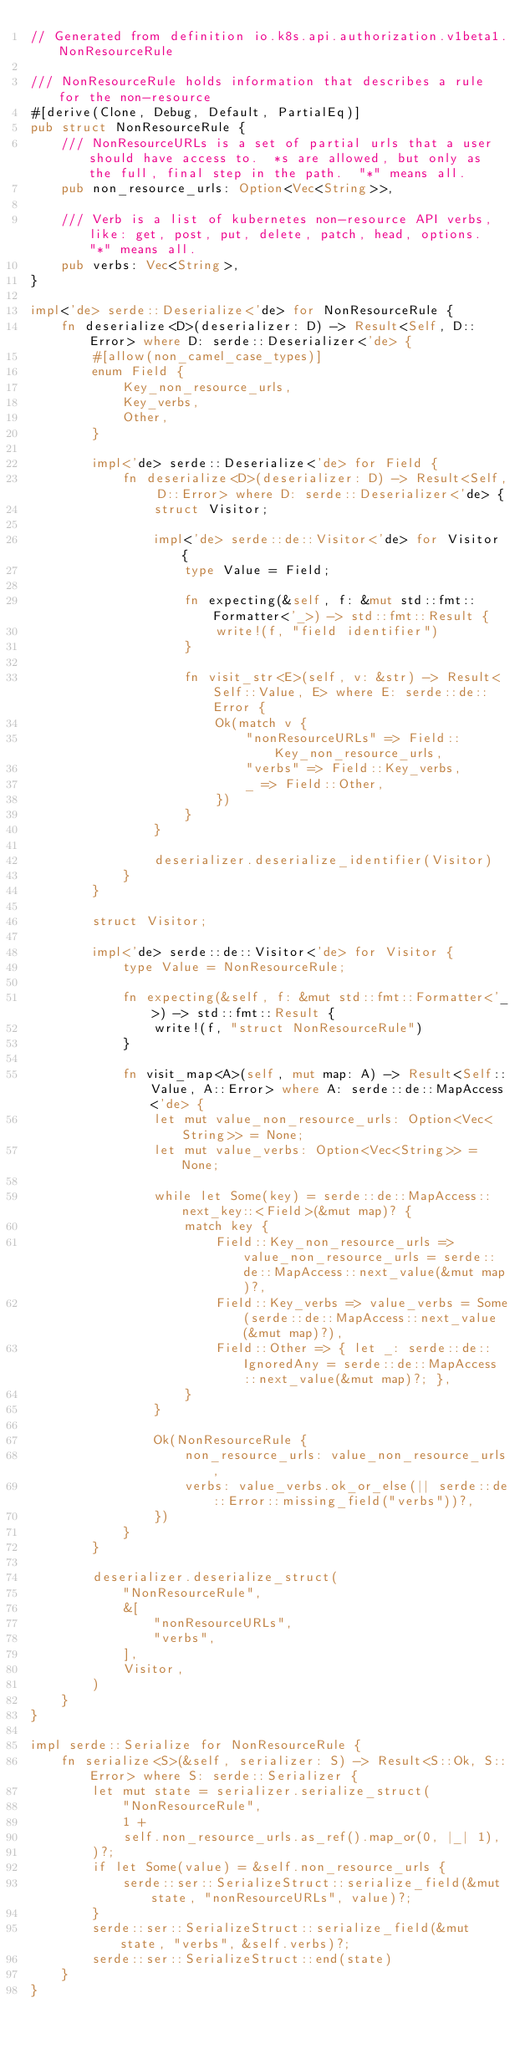<code> <loc_0><loc_0><loc_500><loc_500><_Rust_>// Generated from definition io.k8s.api.authorization.v1beta1.NonResourceRule

/// NonResourceRule holds information that describes a rule for the non-resource
#[derive(Clone, Debug, Default, PartialEq)]
pub struct NonResourceRule {
    /// NonResourceURLs is a set of partial urls that a user should have access to.  *s are allowed, but only as the full, final step in the path.  "*" means all.
    pub non_resource_urls: Option<Vec<String>>,

    /// Verb is a list of kubernetes non-resource API verbs, like: get, post, put, delete, patch, head, options.  "*" means all.
    pub verbs: Vec<String>,
}

impl<'de> serde::Deserialize<'de> for NonResourceRule {
    fn deserialize<D>(deserializer: D) -> Result<Self, D::Error> where D: serde::Deserializer<'de> {
        #[allow(non_camel_case_types)]
        enum Field {
            Key_non_resource_urls,
            Key_verbs,
            Other,
        }

        impl<'de> serde::Deserialize<'de> for Field {
            fn deserialize<D>(deserializer: D) -> Result<Self, D::Error> where D: serde::Deserializer<'de> {
                struct Visitor;

                impl<'de> serde::de::Visitor<'de> for Visitor {
                    type Value = Field;

                    fn expecting(&self, f: &mut std::fmt::Formatter<'_>) -> std::fmt::Result {
                        write!(f, "field identifier")
                    }

                    fn visit_str<E>(self, v: &str) -> Result<Self::Value, E> where E: serde::de::Error {
                        Ok(match v {
                            "nonResourceURLs" => Field::Key_non_resource_urls,
                            "verbs" => Field::Key_verbs,
                            _ => Field::Other,
                        })
                    }
                }

                deserializer.deserialize_identifier(Visitor)
            }
        }

        struct Visitor;

        impl<'de> serde::de::Visitor<'de> for Visitor {
            type Value = NonResourceRule;

            fn expecting(&self, f: &mut std::fmt::Formatter<'_>) -> std::fmt::Result {
                write!(f, "struct NonResourceRule")
            }

            fn visit_map<A>(self, mut map: A) -> Result<Self::Value, A::Error> where A: serde::de::MapAccess<'de> {
                let mut value_non_resource_urls: Option<Vec<String>> = None;
                let mut value_verbs: Option<Vec<String>> = None;

                while let Some(key) = serde::de::MapAccess::next_key::<Field>(&mut map)? {
                    match key {
                        Field::Key_non_resource_urls => value_non_resource_urls = serde::de::MapAccess::next_value(&mut map)?,
                        Field::Key_verbs => value_verbs = Some(serde::de::MapAccess::next_value(&mut map)?),
                        Field::Other => { let _: serde::de::IgnoredAny = serde::de::MapAccess::next_value(&mut map)?; },
                    }
                }

                Ok(NonResourceRule {
                    non_resource_urls: value_non_resource_urls,
                    verbs: value_verbs.ok_or_else(|| serde::de::Error::missing_field("verbs"))?,
                })
            }
        }

        deserializer.deserialize_struct(
            "NonResourceRule",
            &[
                "nonResourceURLs",
                "verbs",
            ],
            Visitor,
        )
    }
}

impl serde::Serialize for NonResourceRule {
    fn serialize<S>(&self, serializer: S) -> Result<S::Ok, S::Error> where S: serde::Serializer {
        let mut state = serializer.serialize_struct(
            "NonResourceRule",
            1 +
            self.non_resource_urls.as_ref().map_or(0, |_| 1),
        )?;
        if let Some(value) = &self.non_resource_urls {
            serde::ser::SerializeStruct::serialize_field(&mut state, "nonResourceURLs", value)?;
        }
        serde::ser::SerializeStruct::serialize_field(&mut state, "verbs", &self.verbs)?;
        serde::ser::SerializeStruct::end(state)
    }
}
</code> 